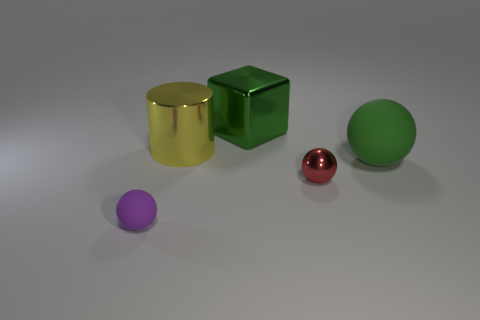There is a ball right of the tiny thing right of the purple ball; what is its color?
Your answer should be very brief. Green. Does the green cube have the same size as the yellow metal cylinder?
Provide a short and direct response. Yes. What number of cylinders are either objects or tiny purple matte things?
Make the answer very short. 1. How many red shiny things are behind the green thing right of the metallic sphere?
Ensure brevity in your answer.  0. Is the big green shiny object the same shape as the big green matte object?
Provide a short and direct response. No. There is a shiny thing that is the same shape as the big matte thing; what size is it?
Give a very brief answer. Small. The rubber thing on the right side of the matte object that is left of the big sphere is what shape?
Ensure brevity in your answer.  Sphere. The yellow cylinder has what size?
Your answer should be very brief. Large. What is the shape of the purple matte object?
Provide a short and direct response. Sphere. Do the big matte thing and the tiny object that is on the left side of the red sphere have the same shape?
Your answer should be compact. Yes. 